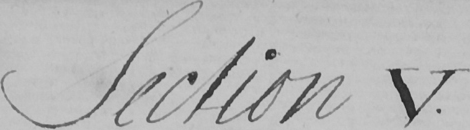Can you read and transcribe this handwriting? Section V . 